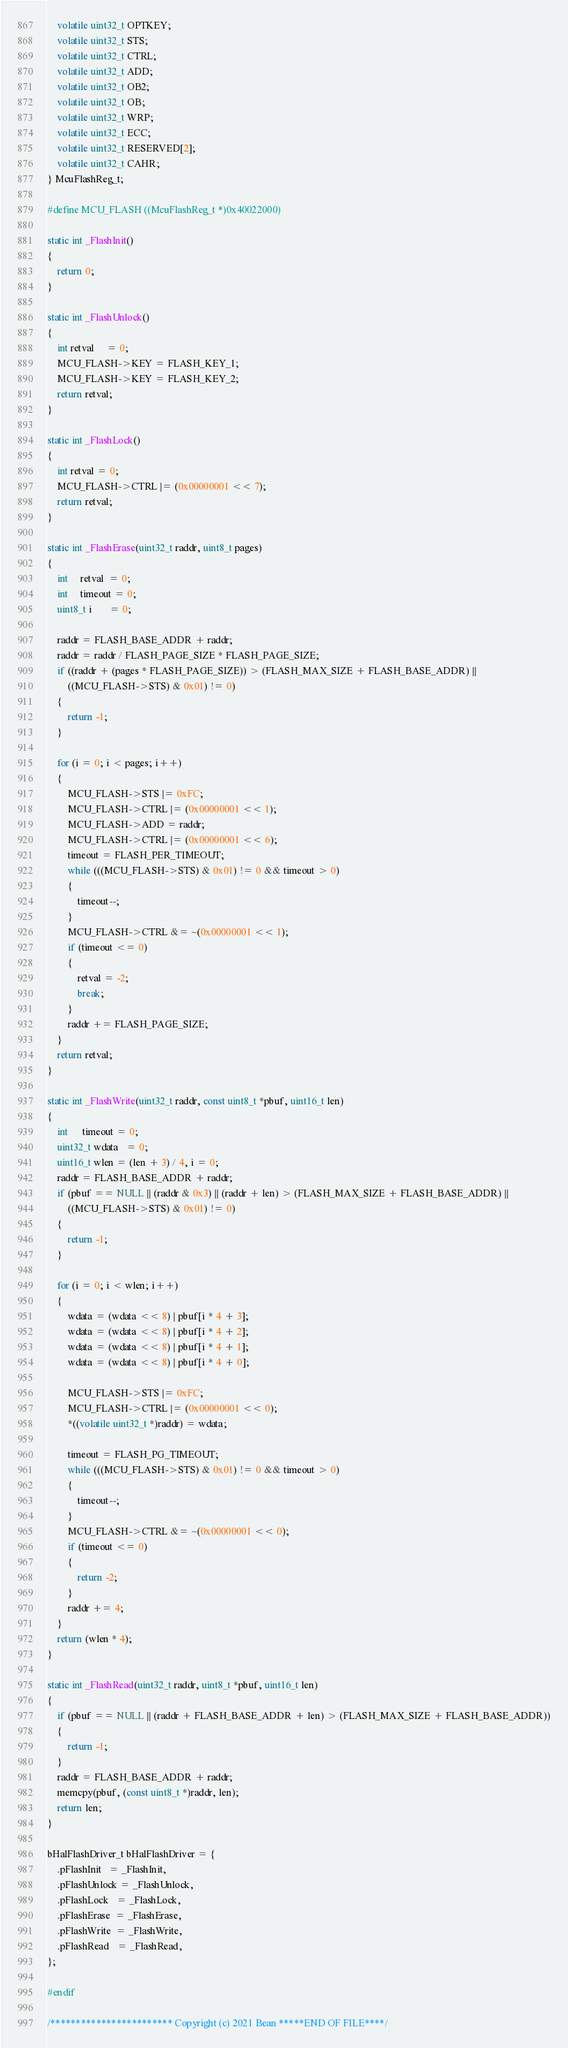<code> <loc_0><loc_0><loc_500><loc_500><_C_>    volatile uint32_t OPTKEY;
    volatile uint32_t STS;
    volatile uint32_t CTRL;
    volatile uint32_t ADD;
    volatile uint32_t OB2;
    volatile uint32_t OB;
    volatile uint32_t WRP;
    volatile uint32_t ECC;
    volatile uint32_t RESERVED[2];
    volatile uint32_t CAHR;
} McuFlashReg_t;

#define MCU_FLASH ((McuFlashReg_t *)0x40022000)

static int _FlashInit()
{
    return 0;
}

static int _FlashUnlock()
{
    int retval     = 0;
    MCU_FLASH->KEY = FLASH_KEY_1;
    MCU_FLASH->KEY = FLASH_KEY_2;
    return retval;
}

static int _FlashLock()
{
    int retval = 0;
    MCU_FLASH->CTRL |= (0x00000001 << 7);
    return retval;
}

static int _FlashErase(uint32_t raddr, uint8_t pages)
{
    int     retval  = 0;
    int     timeout = 0;
    uint8_t i       = 0;

    raddr = FLASH_BASE_ADDR + raddr;
    raddr = raddr / FLASH_PAGE_SIZE * FLASH_PAGE_SIZE;
    if ((raddr + (pages * FLASH_PAGE_SIZE)) > (FLASH_MAX_SIZE + FLASH_BASE_ADDR) ||
        ((MCU_FLASH->STS) & 0x01) != 0)
    {
        return -1;
    }

    for (i = 0; i < pages; i++)
    {
        MCU_FLASH->STS |= 0xFC;
        MCU_FLASH->CTRL |= (0x00000001 << 1);
        MCU_FLASH->ADD = raddr;
        MCU_FLASH->CTRL |= (0x00000001 << 6);
        timeout = FLASH_PER_TIMEOUT;
        while (((MCU_FLASH->STS) & 0x01) != 0 && timeout > 0)
        {
            timeout--;
        }
        MCU_FLASH->CTRL &= ~(0x00000001 << 1);
        if (timeout <= 0)
        {
            retval = -2;
            break;
        }
        raddr += FLASH_PAGE_SIZE;
    }
    return retval;
}

static int _FlashWrite(uint32_t raddr, const uint8_t *pbuf, uint16_t len)
{
    int      timeout = 0;
    uint32_t wdata   = 0;
    uint16_t wlen = (len + 3) / 4, i = 0;
    raddr = FLASH_BASE_ADDR + raddr;
    if (pbuf == NULL || (raddr & 0x3) || (raddr + len) > (FLASH_MAX_SIZE + FLASH_BASE_ADDR) ||
        ((MCU_FLASH->STS) & 0x01) != 0)
    {
        return -1;
    }

    for (i = 0; i < wlen; i++)
    {
        wdata = (wdata << 8) | pbuf[i * 4 + 3];
        wdata = (wdata << 8) | pbuf[i * 4 + 2];
        wdata = (wdata << 8) | pbuf[i * 4 + 1];
        wdata = (wdata << 8) | pbuf[i * 4 + 0];

        MCU_FLASH->STS |= 0xFC;
        MCU_FLASH->CTRL |= (0x00000001 << 0);
        *((volatile uint32_t *)raddr) = wdata;

        timeout = FLASH_PG_TIMEOUT;
        while (((MCU_FLASH->STS) & 0x01) != 0 && timeout > 0)
        {
            timeout--;
        }
        MCU_FLASH->CTRL &= ~(0x00000001 << 0);
        if (timeout <= 0)
        {
            return -2;
        }
        raddr += 4;
    }
    return (wlen * 4);
}

static int _FlashRead(uint32_t raddr, uint8_t *pbuf, uint16_t len)
{
    if (pbuf == NULL || (raddr + FLASH_BASE_ADDR + len) > (FLASH_MAX_SIZE + FLASH_BASE_ADDR))
    {
        return -1;
    }
    raddr = FLASH_BASE_ADDR + raddr;
    memcpy(pbuf, (const uint8_t *)raddr, len);
    return len;
}

bHalFlashDriver_t bHalFlashDriver = {
    .pFlashInit   = _FlashInit,
    .pFlashUnlock = _FlashUnlock,
    .pFlashLock   = _FlashLock,
    .pFlashErase  = _FlashErase,
    .pFlashWrite  = _FlashWrite,
    .pFlashRead   = _FlashRead,
};

#endif

/************************ Copyright (c) 2021 Bean *****END OF FILE****/
</code> 